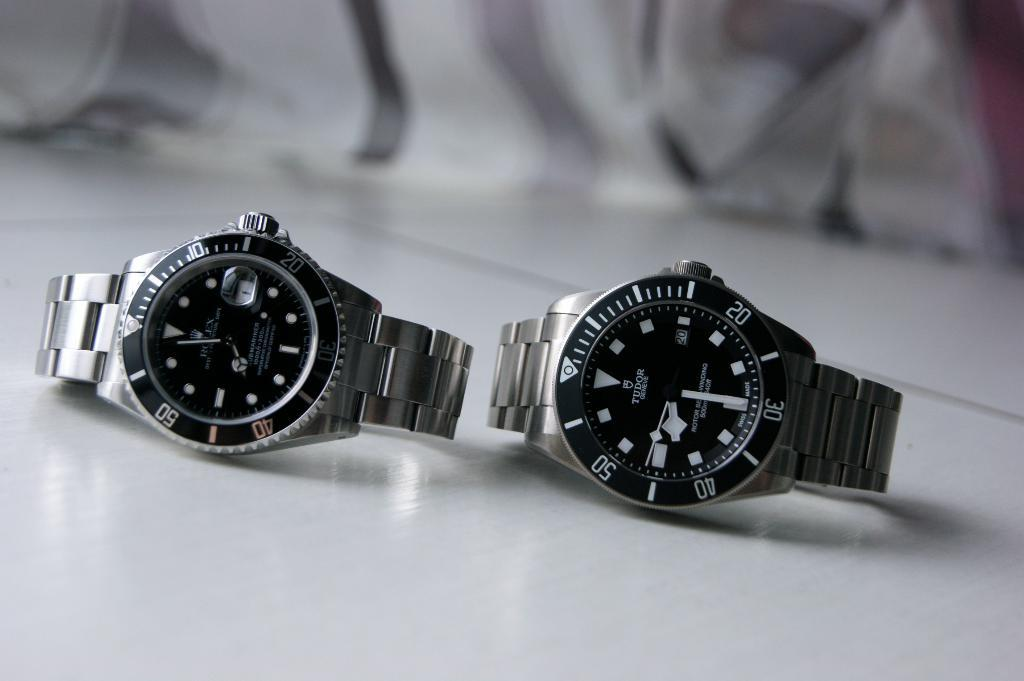<image>
Offer a succinct explanation of the picture presented. Silver and black watch which says TUDOR on it. 